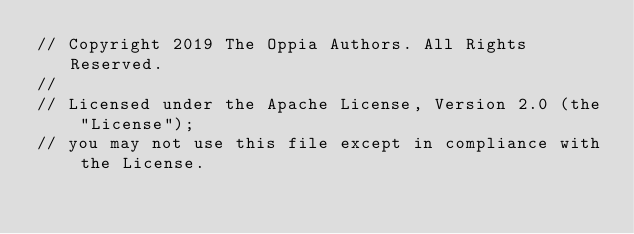Convert code to text. <code><loc_0><loc_0><loc_500><loc_500><_TypeScript_>// Copyright 2019 The Oppia Authors. All Rights Reserved.
//
// Licensed under the Apache License, Version 2.0 (the "License");
// you may not use this file except in compliance with the License.</code> 